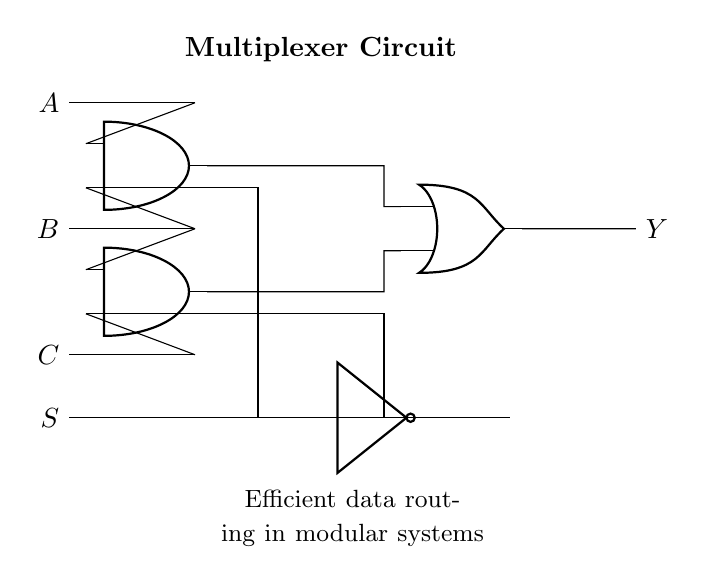What components are present in this circuit? The circuit includes two AND gates, one OR gate, and a NOT gate, along with input lines A, B, C, and a selection line S.
Answer: AND gates, OR gate, NOT gate What is the output of the circuit labeled as? The output from the circuit is labeled as Y, which indicates the result of the logic processing based on the inputs and selection signal.
Answer: Y How many input lines are present in this circuit? There are three input lines denoted as A, B, and C, each feeding into the AND gates for logical processing.
Answer: 3 Which gates are involved in the selection process of the multiplexer? The AND gates utilize the selection line S to determine which input combination is sent to the output, effectively routing the data based on the selection.
Answer: AND gates If the selection line S is high, which AND gate produces a high output? When the selection line S is high, the first AND gate produces a high output if both of its inputs A and B are also high, effectively selecting that data channel.
Answer: First AND gate What is the function of the NOT gate in this circuit? The NOT gate inverts the selection line input, providing the necessary signal to control the second AND gate, which ensures that the correct data path is chosen based on the selection logic.
Answer: Inverting the selection signal How many outputs are connected to the OR gate? The OR gate receives two outputs from both AND gates, combining their results to produce the final output Y based on which AND gate is triggered by the selection line.
Answer: 2 